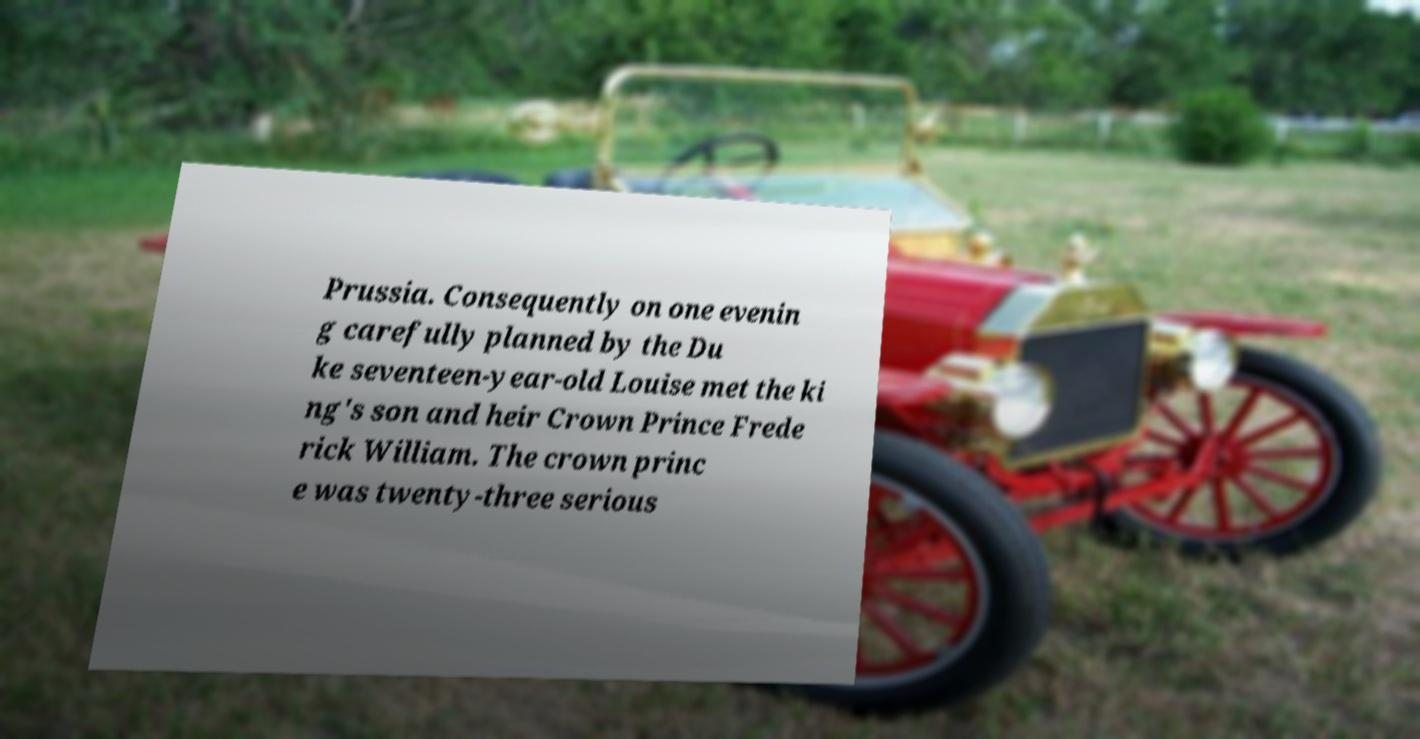Please identify and transcribe the text found in this image. Prussia. Consequently on one evenin g carefully planned by the Du ke seventeen-year-old Louise met the ki ng's son and heir Crown Prince Frede rick William. The crown princ e was twenty-three serious 